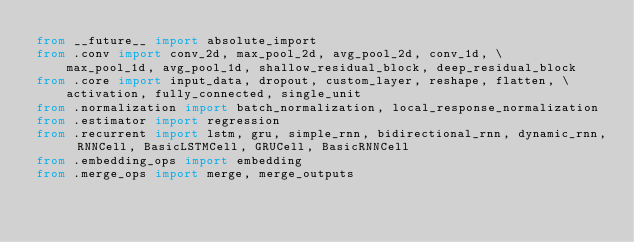<code> <loc_0><loc_0><loc_500><loc_500><_Python_>from __future__ import absolute_import
from .conv import conv_2d, max_pool_2d, avg_pool_2d, conv_1d, \
    max_pool_1d, avg_pool_1d, shallow_residual_block, deep_residual_block
from .core import input_data, dropout, custom_layer, reshape, flatten, \
    activation, fully_connected, single_unit
from .normalization import batch_normalization, local_response_normalization
from .estimator import regression
from .recurrent import lstm, gru, simple_rnn, bidirectional_rnn, dynamic_rnn, RNNCell, BasicLSTMCell, GRUCell, BasicRNNCell
from .embedding_ops import embedding
from .merge_ops import merge, merge_outputs
</code> 